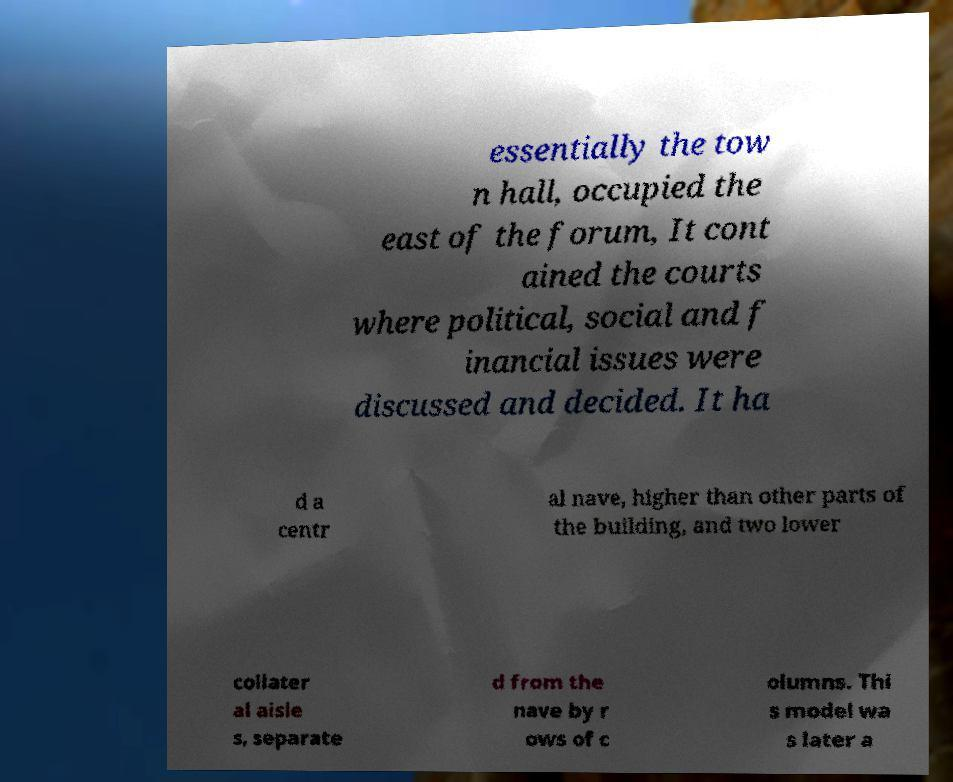For documentation purposes, I need the text within this image transcribed. Could you provide that? essentially the tow n hall, occupied the east of the forum, It cont ained the courts where political, social and f inancial issues were discussed and decided. It ha d a centr al nave, higher than other parts of the building, and two lower collater al aisle s, separate d from the nave by r ows of c olumns. Thi s model wa s later a 